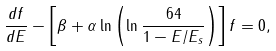Convert formula to latex. <formula><loc_0><loc_0><loc_500><loc_500>\frac { d f } { d E } - \left [ \beta + \alpha \ln \left ( \ln \frac { 6 4 } { 1 - E / E _ { s } } \right ) \right ] f = 0 ,</formula> 